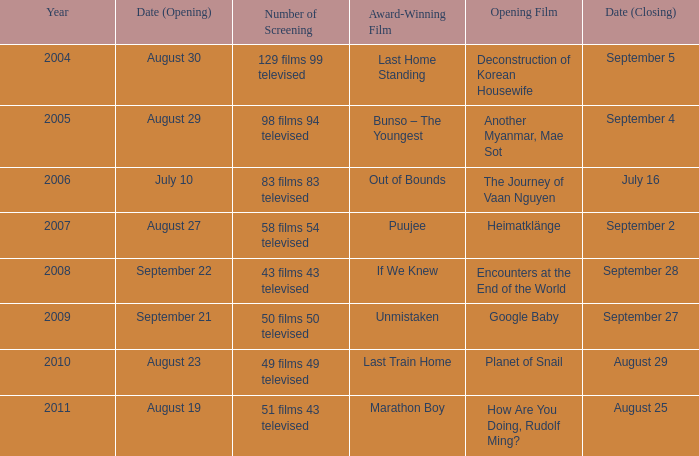How many number of screenings have an opening film of the journey of vaan nguyen? 1.0. 